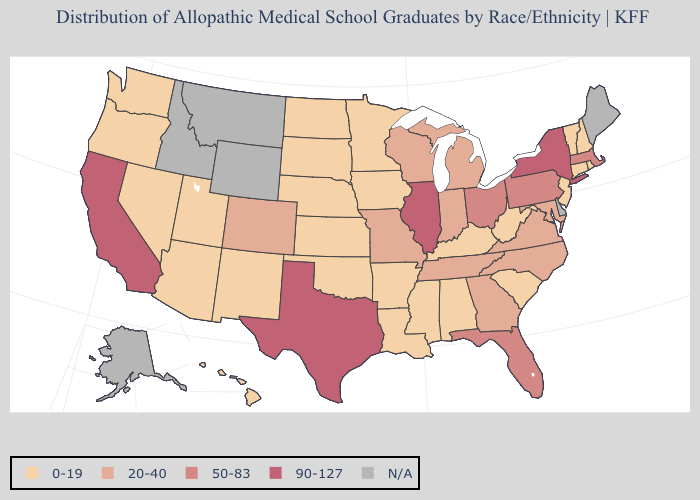Does the map have missing data?
Write a very short answer. Yes. Name the states that have a value in the range 90-127?
Keep it brief. California, Illinois, New York, Texas. Does California have the highest value in the USA?
Write a very short answer. Yes. Name the states that have a value in the range 20-40?
Be succinct. Colorado, Georgia, Indiana, Maryland, Michigan, Missouri, North Carolina, Tennessee, Virginia, Wisconsin. Which states have the highest value in the USA?
Give a very brief answer. California, Illinois, New York, Texas. Among the states that border New Hampshire , which have the lowest value?
Be succinct. Vermont. What is the lowest value in the USA?
Short answer required. 0-19. Does the first symbol in the legend represent the smallest category?
Concise answer only. Yes. Name the states that have a value in the range 0-19?
Short answer required. Alabama, Arizona, Arkansas, Connecticut, Hawaii, Iowa, Kansas, Kentucky, Louisiana, Minnesota, Mississippi, Nebraska, Nevada, New Hampshire, New Jersey, New Mexico, North Dakota, Oklahoma, Oregon, Rhode Island, South Carolina, South Dakota, Utah, Vermont, Washington, West Virginia. Does New Hampshire have the lowest value in the Northeast?
Short answer required. Yes. Name the states that have a value in the range 20-40?
Short answer required. Colorado, Georgia, Indiana, Maryland, Michigan, Missouri, North Carolina, Tennessee, Virginia, Wisconsin. What is the highest value in the Northeast ?
Be succinct. 90-127. Name the states that have a value in the range N/A?
Answer briefly. Alaska, Delaware, Idaho, Maine, Montana, Wyoming. Which states hav the highest value in the MidWest?
Concise answer only. Illinois. 